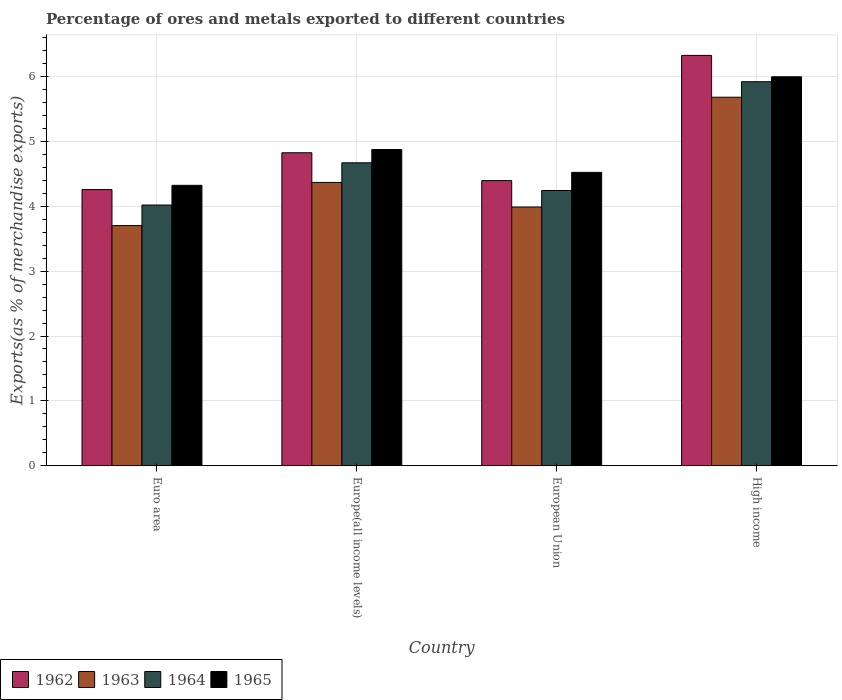How many different coloured bars are there?
Keep it short and to the point. 4. Are the number of bars on each tick of the X-axis equal?
Provide a short and direct response. Yes. How many bars are there on the 3rd tick from the left?
Your answer should be compact. 4. What is the label of the 2nd group of bars from the left?
Your answer should be compact. Europe(all income levels). What is the percentage of exports to different countries in 1962 in High income?
Keep it short and to the point. 6.33. Across all countries, what is the maximum percentage of exports to different countries in 1964?
Your answer should be very brief. 5.92. Across all countries, what is the minimum percentage of exports to different countries in 1964?
Offer a very short reply. 4.02. In which country was the percentage of exports to different countries in 1963 minimum?
Your answer should be very brief. Euro area. What is the total percentage of exports to different countries in 1965 in the graph?
Provide a short and direct response. 19.72. What is the difference between the percentage of exports to different countries in 1964 in European Union and that in High income?
Keep it short and to the point. -1.68. What is the difference between the percentage of exports to different countries in 1963 in Euro area and the percentage of exports to different countries in 1965 in High income?
Offer a very short reply. -2.29. What is the average percentage of exports to different countries in 1963 per country?
Give a very brief answer. 4.44. What is the difference between the percentage of exports to different countries of/in 1965 and percentage of exports to different countries of/in 1962 in High income?
Ensure brevity in your answer.  -0.33. In how many countries, is the percentage of exports to different countries in 1963 greater than 2.8 %?
Your answer should be compact. 4. What is the ratio of the percentage of exports to different countries in 1965 in Europe(all income levels) to that in High income?
Your response must be concise. 0.81. What is the difference between the highest and the second highest percentage of exports to different countries in 1962?
Keep it short and to the point. 0.43. What is the difference between the highest and the lowest percentage of exports to different countries in 1964?
Keep it short and to the point. 1.9. Is the sum of the percentage of exports to different countries in 1963 in Euro area and European Union greater than the maximum percentage of exports to different countries in 1964 across all countries?
Offer a terse response. Yes. What does the 4th bar from the left in High income represents?
Make the answer very short. 1965. What does the 2nd bar from the right in Europe(all income levels) represents?
Your answer should be very brief. 1964. Is it the case that in every country, the sum of the percentage of exports to different countries in 1964 and percentage of exports to different countries in 1965 is greater than the percentage of exports to different countries in 1963?
Offer a terse response. Yes. Are all the bars in the graph horizontal?
Offer a very short reply. No. How many countries are there in the graph?
Provide a succinct answer. 4. What is the difference between two consecutive major ticks on the Y-axis?
Make the answer very short. 1. Does the graph contain grids?
Offer a terse response. Yes. Where does the legend appear in the graph?
Keep it short and to the point. Bottom left. How many legend labels are there?
Your answer should be compact. 4. What is the title of the graph?
Your response must be concise. Percentage of ores and metals exported to different countries. Does "1985" appear as one of the legend labels in the graph?
Offer a very short reply. No. What is the label or title of the X-axis?
Give a very brief answer. Country. What is the label or title of the Y-axis?
Your answer should be compact. Exports(as % of merchandise exports). What is the Exports(as % of merchandise exports) of 1962 in Euro area?
Ensure brevity in your answer.  4.26. What is the Exports(as % of merchandise exports) in 1963 in Euro area?
Provide a short and direct response. 3.7. What is the Exports(as % of merchandise exports) of 1964 in Euro area?
Your answer should be compact. 4.02. What is the Exports(as % of merchandise exports) in 1965 in Euro area?
Your response must be concise. 4.32. What is the Exports(as % of merchandise exports) of 1962 in Europe(all income levels)?
Provide a short and direct response. 4.83. What is the Exports(as % of merchandise exports) of 1963 in Europe(all income levels)?
Keep it short and to the point. 4.37. What is the Exports(as % of merchandise exports) of 1964 in Europe(all income levels)?
Give a very brief answer. 4.67. What is the Exports(as % of merchandise exports) of 1965 in Europe(all income levels)?
Provide a short and direct response. 4.88. What is the Exports(as % of merchandise exports) of 1962 in European Union?
Make the answer very short. 4.4. What is the Exports(as % of merchandise exports) in 1963 in European Union?
Provide a short and direct response. 3.99. What is the Exports(as % of merchandise exports) of 1964 in European Union?
Make the answer very short. 4.24. What is the Exports(as % of merchandise exports) in 1965 in European Union?
Make the answer very short. 4.52. What is the Exports(as % of merchandise exports) of 1962 in High income?
Provide a short and direct response. 6.33. What is the Exports(as % of merchandise exports) in 1963 in High income?
Make the answer very short. 5.68. What is the Exports(as % of merchandise exports) of 1964 in High income?
Offer a very short reply. 5.92. What is the Exports(as % of merchandise exports) of 1965 in High income?
Your answer should be compact. 6. Across all countries, what is the maximum Exports(as % of merchandise exports) of 1962?
Your response must be concise. 6.33. Across all countries, what is the maximum Exports(as % of merchandise exports) in 1963?
Provide a short and direct response. 5.68. Across all countries, what is the maximum Exports(as % of merchandise exports) of 1964?
Offer a terse response. 5.92. Across all countries, what is the maximum Exports(as % of merchandise exports) of 1965?
Your answer should be very brief. 6. Across all countries, what is the minimum Exports(as % of merchandise exports) of 1962?
Offer a very short reply. 4.26. Across all countries, what is the minimum Exports(as % of merchandise exports) in 1963?
Offer a very short reply. 3.7. Across all countries, what is the minimum Exports(as % of merchandise exports) in 1964?
Provide a short and direct response. 4.02. Across all countries, what is the minimum Exports(as % of merchandise exports) in 1965?
Provide a short and direct response. 4.32. What is the total Exports(as % of merchandise exports) of 1962 in the graph?
Provide a succinct answer. 19.81. What is the total Exports(as % of merchandise exports) in 1963 in the graph?
Ensure brevity in your answer.  17.74. What is the total Exports(as % of merchandise exports) of 1964 in the graph?
Offer a terse response. 18.86. What is the total Exports(as % of merchandise exports) in 1965 in the graph?
Offer a very short reply. 19.72. What is the difference between the Exports(as % of merchandise exports) of 1962 in Euro area and that in Europe(all income levels)?
Provide a short and direct response. -0.57. What is the difference between the Exports(as % of merchandise exports) of 1963 in Euro area and that in Europe(all income levels)?
Offer a very short reply. -0.67. What is the difference between the Exports(as % of merchandise exports) in 1964 in Euro area and that in Europe(all income levels)?
Offer a very short reply. -0.65. What is the difference between the Exports(as % of merchandise exports) in 1965 in Euro area and that in Europe(all income levels)?
Provide a short and direct response. -0.55. What is the difference between the Exports(as % of merchandise exports) of 1962 in Euro area and that in European Union?
Make the answer very short. -0.14. What is the difference between the Exports(as % of merchandise exports) of 1963 in Euro area and that in European Union?
Your answer should be compact. -0.29. What is the difference between the Exports(as % of merchandise exports) in 1964 in Euro area and that in European Union?
Give a very brief answer. -0.22. What is the difference between the Exports(as % of merchandise exports) of 1965 in Euro area and that in European Union?
Provide a short and direct response. -0.2. What is the difference between the Exports(as % of merchandise exports) in 1962 in Euro area and that in High income?
Ensure brevity in your answer.  -2.07. What is the difference between the Exports(as % of merchandise exports) of 1963 in Euro area and that in High income?
Give a very brief answer. -1.98. What is the difference between the Exports(as % of merchandise exports) in 1964 in Euro area and that in High income?
Your response must be concise. -1.9. What is the difference between the Exports(as % of merchandise exports) of 1965 in Euro area and that in High income?
Your response must be concise. -1.67. What is the difference between the Exports(as % of merchandise exports) in 1962 in Europe(all income levels) and that in European Union?
Your answer should be very brief. 0.43. What is the difference between the Exports(as % of merchandise exports) in 1963 in Europe(all income levels) and that in European Union?
Provide a succinct answer. 0.38. What is the difference between the Exports(as % of merchandise exports) of 1964 in Europe(all income levels) and that in European Union?
Ensure brevity in your answer.  0.43. What is the difference between the Exports(as % of merchandise exports) in 1965 in Europe(all income levels) and that in European Union?
Offer a very short reply. 0.35. What is the difference between the Exports(as % of merchandise exports) of 1962 in Europe(all income levels) and that in High income?
Your answer should be compact. -1.5. What is the difference between the Exports(as % of merchandise exports) in 1963 in Europe(all income levels) and that in High income?
Your response must be concise. -1.31. What is the difference between the Exports(as % of merchandise exports) in 1964 in Europe(all income levels) and that in High income?
Make the answer very short. -1.25. What is the difference between the Exports(as % of merchandise exports) of 1965 in Europe(all income levels) and that in High income?
Offer a very short reply. -1.12. What is the difference between the Exports(as % of merchandise exports) of 1962 in European Union and that in High income?
Provide a succinct answer. -1.93. What is the difference between the Exports(as % of merchandise exports) in 1963 in European Union and that in High income?
Provide a succinct answer. -1.69. What is the difference between the Exports(as % of merchandise exports) in 1964 in European Union and that in High income?
Offer a terse response. -1.68. What is the difference between the Exports(as % of merchandise exports) of 1965 in European Union and that in High income?
Make the answer very short. -1.47. What is the difference between the Exports(as % of merchandise exports) of 1962 in Euro area and the Exports(as % of merchandise exports) of 1963 in Europe(all income levels)?
Provide a short and direct response. -0.11. What is the difference between the Exports(as % of merchandise exports) of 1962 in Euro area and the Exports(as % of merchandise exports) of 1964 in Europe(all income levels)?
Give a very brief answer. -0.41. What is the difference between the Exports(as % of merchandise exports) in 1962 in Euro area and the Exports(as % of merchandise exports) in 1965 in Europe(all income levels)?
Your answer should be compact. -0.62. What is the difference between the Exports(as % of merchandise exports) in 1963 in Euro area and the Exports(as % of merchandise exports) in 1964 in Europe(all income levels)?
Offer a very short reply. -0.97. What is the difference between the Exports(as % of merchandise exports) in 1963 in Euro area and the Exports(as % of merchandise exports) in 1965 in Europe(all income levels)?
Keep it short and to the point. -1.17. What is the difference between the Exports(as % of merchandise exports) of 1964 in Euro area and the Exports(as % of merchandise exports) of 1965 in Europe(all income levels)?
Offer a terse response. -0.86. What is the difference between the Exports(as % of merchandise exports) of 1962 in Euro area and the Exports(as % of merchandise exports) of 1963 in European Union?
Your response must be concise. 0.27. What is the difference between the Exports(as % of merchandise exports) of 1962 in Euro area and the Exports(as % of merchandise exports) of 1964 in European Union?
Make the answer very short. 0.01. What is the difference between the Exports(as % of merchandise exports) of 1962 in Euro area and the Exports(as % of merchandise exports) of 1965 in European Union?
Offer a terse response. -0.27. What is the difference between the Exports(as % of merchandise exports) of 1963 in Euro area and the Exports(as % of merchandise exports) of 1964 in European Union?
Your answer should be very brief. -0.54. What is the difference between the Exports(as % of merchandise exports) in 1963 in Euro area and the Exports(as % of merchandise exports) in 1965 in European Union?
Offer a very short reply. -0.82. What is the difference between the Exports(as % of merchandise exports) in 1964 in Euro area and the Exports(as % of merchandise exports) in 1965 in European Union?
Provide a short and direct response. -0.5. What is the difference between the Exports(as % of merchandise exports) of 1962 in Euro area and the Exports(as % of merchandise exports) of 1963 in High income?
Your response must be concise. -1.42. What is the difference between the Exports(as % of merchandise exports) of 1962 in Euro area and the Exports(as % of merchandise exports) of 1964 in High income?
Provide a succinct answer. -1.66. What is the difference between the Exports(as % of merchandise exports) of 1962 in Euro area and the Exports(as % of merchandise exports) of 1965 in High income?
Keep it short and to the point. -1.74. What is the difference between the Exports(as % of merchandise exports) of 1963 in Euro area and the Exports(as % of merchandise exports) of 1964 in High income?
Your answer should be very brief. -2.22. What is the difference between the Exports(as % of merchandise exports) of 1963 in Euro area and the Exports(as % of merchandise exports) of 1965 in High income?
Provide a succinct answer. -2.29. What is the difference between the Exports(as % of merchandise exports) of 1964 in Euro area and the Exports(as % of merchandise exports) of 1965 in High income?
Provide a succinct answer. -1.98. What is the difference between the Exports(as % of merchandise exports) in 1962 in Europe(all income levels) and the Exports(as % of merchandise exports) in 1963 in European Union?
Offer a terse response. 0.84. What is the difference between the Exports(as % of merchandise exports) of 1962 in Europe(all income levels) and the Exports(as % of merchandise exports) of 1964 in European Union?
Your answer should be compact. 0.58. What is the difference between the Exports(as % of merchandise exports) of 1962 in Europe(all income levels) and the Exports(as % of merchandise exports) of 1965 in European Union?
Keep it short and to the point. 0.3. What is the difference between the Exports(as % of merchandise exports) of 1963 in Europe(all income levels) and the Exports(as % of merchandise exports) of 1964 in European Union?
Offer a very short reply. 0.12. What is the difference between the Exports(as % of merchandise exports) of 1963 in Europe(all income levels) and the Exports(as % of merchandise exports) of 1965 in European Union?
Your answer should be very brief. -0.16. What is the difference between the Exports(as % of merchandise exports) of 1964 in Europe(all income levels) and the Exports(as % of merchandise exports) of 1965 in European Union?
Provide a succinct answer. 0.15. What is the difference between the Exports(as % of merchandise exports) of 1962 in Europe(all income levels) and the Exports(as % of merchandise exports) of 1963 in High income?
Provide a succinct answer. -0.86. What is the difference between the Exports(as % of merchandise exports) in 1962 in Europe(all income levels) and the Exports(as % of merchandise exports) in 1964 in High income?
Keep it short and to the point. -1.1. What is the difference between the Exports(as % of merchandise exports) in 1962 in Europe(all income levels) and the Exports(as % of merchandise exports) in 1965 in High income?
Offer a very short reply. -1.17. What is the difference between the Exports(as % of merchandise exports) of 1963 in Europe(all income levels) and the Exports(as % of merchandise exports) of 1964 in High income?
Your response must be concise. -1.55. What is the difference between the Exports(as % of merchandise exports) of 1963 in Europe(all income levels) and the Exports(as % of merchandise exports) of 1965 in High income?
Offer a very short reply. -1.63. What is the difference between the Exports(as % of merchandise exports) of 1964 in Europe(all income levels) and the Exports(as % of merchandise exports) of 1965 in High income?
Give a very brief answer. -1.33. What is the difference between the Exports(as % of merchandise exports) of 1962 in European Union and the Exports(as % of merchandise exports) of 1963 in High income?
Make the answer very short. -1.29. What is the difference between the Exports(as % of merchandise exports) in 1962 in European Union and the Exports(as % of merchandise exports) in 1964 in High income?
Offer a terse response. -1.53. What is the difference between the Exports(as % of merchandise exports) of 1962 in European Union and the Exports(as % of merchandise exports) of 1965 in High income?
Offer a very short reply. -1.6. What is the difference between the Exports(as % of merchandise exports) of 1963 in European Union and the Exports(as % of merchandise exports) of 1964 in High income?
Offer a terse response. -1.93. What is the difference between the Exports(as % of merchandise exports) in 1963 in European Union and the Exports(as % of merchandise exports) in 1965 in High income?
Your answer should be very brief. -2.01. What is the difference between the Exports(as % of merchandise exports) of 1964 in European Union and the Exports(as % of merchandise exports) of 1965 in High income?
Offer a very short reply. -1.75. What is the average Exports(as % of merchandise exports) in 1962 per country?
Give a very brief answer. 4.95. What is the average Exports(as % of merchandise exports) in 1963 per country?
Offer a terse response. 4.44. What is the average Exports(as % of merchandise exports) in 1964 per country?
Your answer should be compact. 4.71. What is the average Exports(as % of merchandise exports) in 1965 per country?
Keep it short and to the point. 4.93. What is the difference between the Exports(as % of merchandise exports) of 1962 and Exports(as % of merchandise exports) of 1963 in Euro area?
Make the answer very short. 0.56. What is the difference between the Exports(as % of merchandise exports) of 1962 and Exports(as % of merchandise exports) of 1964 in Euro area?
Your answer should be compact. 0.24. What is the difference between the Exports(as % of merchandise exports) in 1962 and Exports(as % of merchandise exports) in 1965 in Euro area?
Keep it short and to the point. -0.07. What is the difference between the Exports(as % of merchandise exports) in 1963 and Exports(as % of merchandise exports) in 1964 in Euro area?
Give a very brief answer. -0.32. What is the difference between the Exports(as % of merchandise exports) of 1963 and Exports(as % of merchandise exports) of 1965 in Euro area?
Offer a terse response. -0.62. What is the difference between the Exports(as % of merchandise exports) of 1964 and Exports(as % of merchandise exports) of 1965 in Euro area?
Give a very brief answer. -0.3. What is the difference between the Exports(as % of merchandise exports) of 1962 and Exports(as % of merchandise exports) of 1963 in Europe(all income levels)?
Give a very brief answer. 0.46. What is the difference between the Exports(as % of merchandise exports) of 1962 and Exports(as % of merchandise exports) of 1964 in Europe(all income levels)?
Ensure brevity in your answer.  0.15. What is the difference between the Exports(as % of merchandise exports) of 1962 and Exports(as % of merchandise exports) of 1965 in Europe(all income levels)?
Provide a succinct answer. -0.05. What is the difference between the Exports(as % of merchandise exports) of 1963 and Exports(as % of merchandise exports) of 1964 in Europe(all income levels)?
Your answer should be very brief. -0.3. What is the difference between the Exports(as % of merchandise exports) of 1963 and Exports(as % of merchandise exports) of 1965 in Europe(all income levels)?
Keep it short and to the point. -0.51. What is the difference between the Exports(as % of merchandise exports) of 1964 and Exports(as % of merchandise exports) of 1965 in Europe(all income levels)?
Your response must be concise. -0.2. What is the difference between the Exports(as % of merchandise exports) of 1962 and Exports(as % of merchandise exports) of 1963 in European Union?
Keep it short and to the point. 0.41. What is the difference between the Exports(as % of merchandise exports) in 1962 and Exports(as % of merchandise exports) in 1964 in European Union?
Keep it short and to the point. 0.15. What is the difference between the Exports(as % of merchandise exports) in 1962 and Exports(as % of merchandise exports) in 1965 in European Union?
Your answer should be very brief. -0.13. What is the difference between the Exports(as % of merchandise exports) of 1963 and Exports(as % of merchandise exports) of 1964 in European Union?
Provide a succinct answer. -0.25. What is the difference between the Exports(as % of merchandise exports) of 1963 and Exports(as % of merchandise exports) of 1965 in European Union?
Keep it short and to the point. -0.53. What is the difference between the Exports(as % of merchandise exports) of 1964 and Exports(as % of merchandise exports) of 1965 in European Union?
Offer a very short reply. -0.28. What is the difference between the Exports(as % of merchandise exports) of 1962 and Exports(as % of merchandise exports) of 1963 in High income?
Offer a terse response. 0.64. What is the difference between the Exports(as % of merchandise exports) of 1962 and Exports(as % of merchandise exports) of 1964 in High income?
Provide a succinct answer. 0.41. What is the difference between the Exports(as % of merchandise exports) in 1962 and Exports(as % of merchandise exports) in 1965 in High income?
Provide a succinct answer. 0.33. What is the difference between the Exports(as % of merchandise exports) in 1963 and Exports(as % of merchandise exports) in 1964 in High income?
Offer a terse response. -0.24. What is the difference between the Exports(as % of merchandise exports) of 1963 and Exports(as % of merchandise exports) of 1965 in High income?
Your answer should be compact. -0.31. What is the difference between the Exports(as % of merchandise exports) in 1964 and Exports(as % of merchandise exports) in 1965 in High income?
Give a very brief answer. -0.08. What is the ratio of the Exports(as % of merchandise exports) in 1962 in Euro area to that in Europe(all income levels)?
Ensure brevity in your answer.  0.88. What is the ratio of the Exports(as % of merchandise exports) in 1963 in Euro area to that in Europe(all income levels)?
Provide a succinct answer. 0.85. What is the ratio of the Exports(as % of merchandise exports) of 1964 in Euro area to that in Europe(all income levels)?
Give a very brief answer. 0.86. What is the ratio of the Exports(as % of merchandise exports) in 1965 in Euro area to that in Europe(all income levels)?
Your response must be concise. 0.89. What is the ratio of the Exports(as % of merchandise exports) of 1962 in Euro area to that in European Union?
Ensure brevity in your answer.  0.97. What is the ratio of the Exports(as % of merchandise exports) of 1963 in Euro area to that in European Union?
Your answer should be compact. 0.93. What is the ratio of the Exports(as % of merchandise exports) of 1964 in Euro area to that in European Union?
Your response must be concise. 0.95. What is the ratio of the Exports(as % of merchandise exports) of 1965 in Euro area to that in European Union?
Your answer should be compact. 0.96. What is the ratio of the Exports(as % of merchandise exports) in 1962 in Euro area to that in High income?
Provide a succinct answer. 0.67. What is the ratio of the Exports(as % of merchandise exports) in 1963 in Euro area to that in High income?
Give a very brief answer. 0.65. What is the ratio of the Exports(as % of merchandise exports) in 1964 in Euro area to that in High income?
Provide a short and direct response. 0.68. What is the ratio of the Exports(as % of merchandise exports) of 1965 in Euro area to that in High income?
Give a very brief answer. 0.72. What is the ratio of the Exports(as % of merchandise exports) in 1962 in Europe(all income levels) to that in European Union?
Your answer should be very brief. 1.1. What is the ratio of the Exports(as % of merchandise exports) of 1963 in Europe(all income levels) to that in European Union?
Give a very brief answer. 1.09. What is the ratio of the Exports(as % of merchandise exports) in 1964 in Europe(all income levels) to that in European Union?
Provide a short and direct response. 1.1. What is the ratio of the Exports(as % of merchandise exports) in 1965 in Europe(all income levels) to that in European Union?
Ensure brevity in your answer.  1.08. What is the ratio of the Exports(as % of merchandise exports) in 1962 in Europe(all income levels) to that in High income?
Your answer should be very brief. 0.76. What is the ratio of the Exports(as % of merchandise exports) of 1963 in Europe(all income levels) to that in High income?
Your response must be concise. 0.77. What is the ratio of the Exports(as % of merchandise exports) in 1964 in Europe(all income levels) to that in High income?
Offer a very short reply. 0.79. What is the ratio of the Exports(as % of merchandise exports) of 1965 in Europe(all income levels) to that in High income?
Your answer should be very brief. 0.81. What is the ratio of the Exports(as % of merchandise exports) of 1962 in European Union to that in High income?
Make the answer very short. 0.69. What is the ratio of the Exports(as % of merchandise exports) in 1963 in European Union to that in High income?
Make the answer very short. 0.7. What is the ratio of the Exports(as % of merchandise exports) of 1964 in European Union to that in High income?
Your answer should be compact. 0.72. What is the ratio of the Exports(as % of merchandise exports) of 1965 in European Union to that in High income?
Make the answer very short. 0.75. What is the difference between the highest and the second highest Exports(as % of merchandise exports) in 1962?
Offer a very short reply. 1.5. What is the difference between the highest and the second highest Exports(as % of merchandise exports) of 1963?
Give a very brief answer. 1.31. What is the difference between the highest and the second highest Exports(as % of merchandise exports) of 1964?
Offer a terse response. 1.25. What is the difference between the highest and the second highest Exports(as % of merchandise exports) of 1965?
Your answer should be compact. 1.12. What is the difference between the highest and the lowest Exports(as % of merchandise exports) of 1962?
Ensure brevity in your answer.  2.07. What is the difference between the highest and the lowest Exports(as % of merchandise exports) of 1963?
Give a very brief answer. 1.98. What is the difference between the highest and the lowest Exports(as % of merchandise exports) in 1964?
Provide a short and direct response. 1.9. What is the difference between the highest and the lowest Exports(as % of merchandise exports) in 1965?
Your response must be concise. 1.67. 